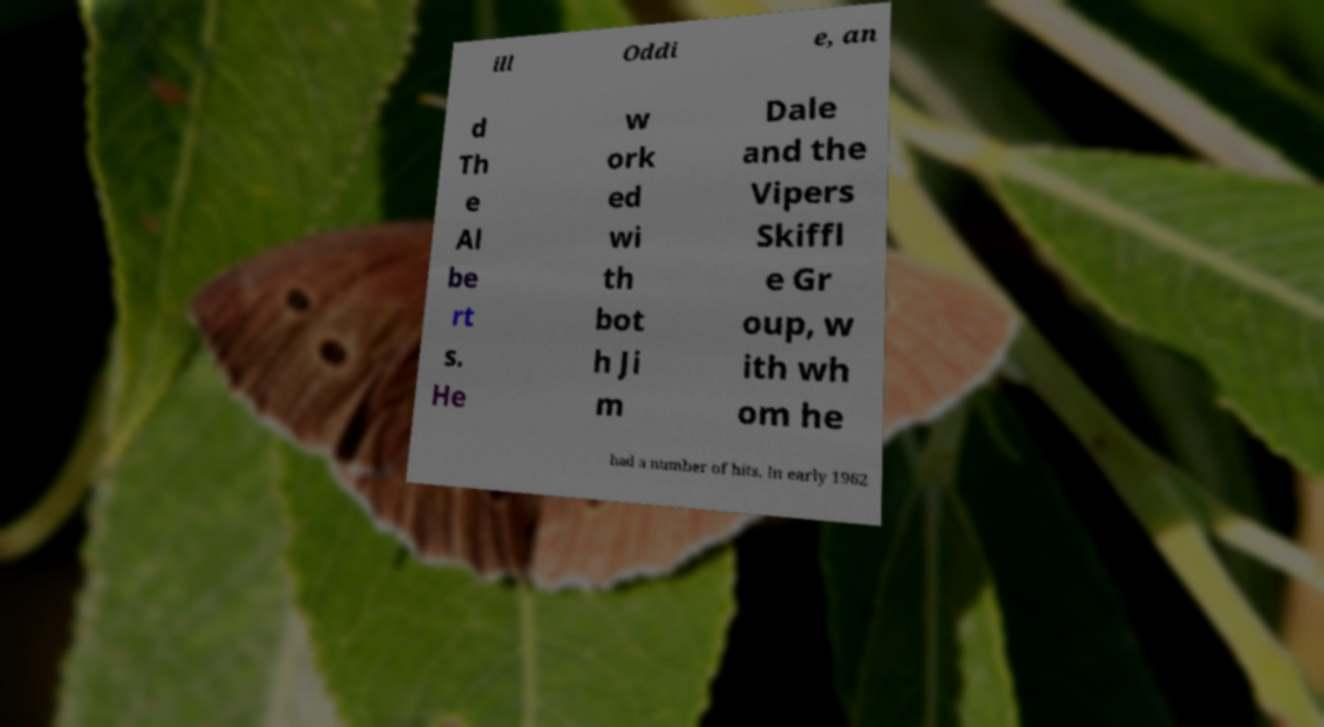I need the written content from this picture converted into text. Can you do that? ill Oddi e, an d Th e Al be rt s. He w ork ed wi th bot h Ji m Dale and the Vipers Skiffl e Gr oup, w ith wh om he had a number of hits. In early 1962 